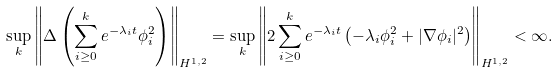<formula> <loc_0><loc_0><loc_500><loc_500>\sup _ { k } \left \| \Delta \left ( \sum _ { i \geq 0 } ^ { k } e ^ { - \lambda _ { i } t } \phi _ { i } ^ { 2 } \right ) \right \| _ { H ^ { 1 , 2 } } = \sup _ { k } \left \| 2 \sum _ { i \geq 0 } ^ { k } e ^ { - \lambda _ { i } t } \left ( - \lambda _ { i } \phi _ { i } ^ { 2 } + | \nabla \phi _ { i } | ^ { 2 } \right ) \right \| _ { H ^ { 1 , 2 } } < \infty .</formula> 